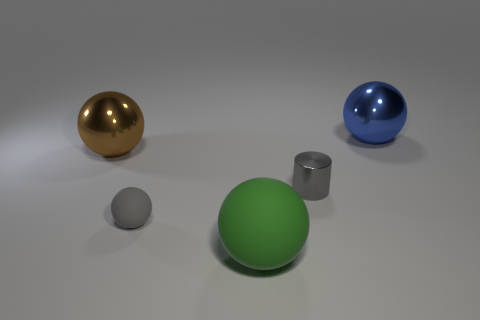Subtract all brown balls. How many balls are left? 3 Subtract all big matte balls. How many balls are left? 3 Add 2 large yellow matte cylinders. How many objects exist? 7 Subtract 2 balls. How many balls are left? 2 Subtract all purple balls. Subtract all brown cylinders. How many balls are left? 4 Subtract all cylinders. How many objects are left? 4 Subtract 1 green spheres. How many objects are left? 4 Subtract all tiny matte things. Subtract all cylinders. How many objects are left? 3 Add 5 tiny gray metal objects. How many tiny gray metal objects are left? 6 Add 4 small blue shiny cubes. How many small blue shiny cubes exist? 4 